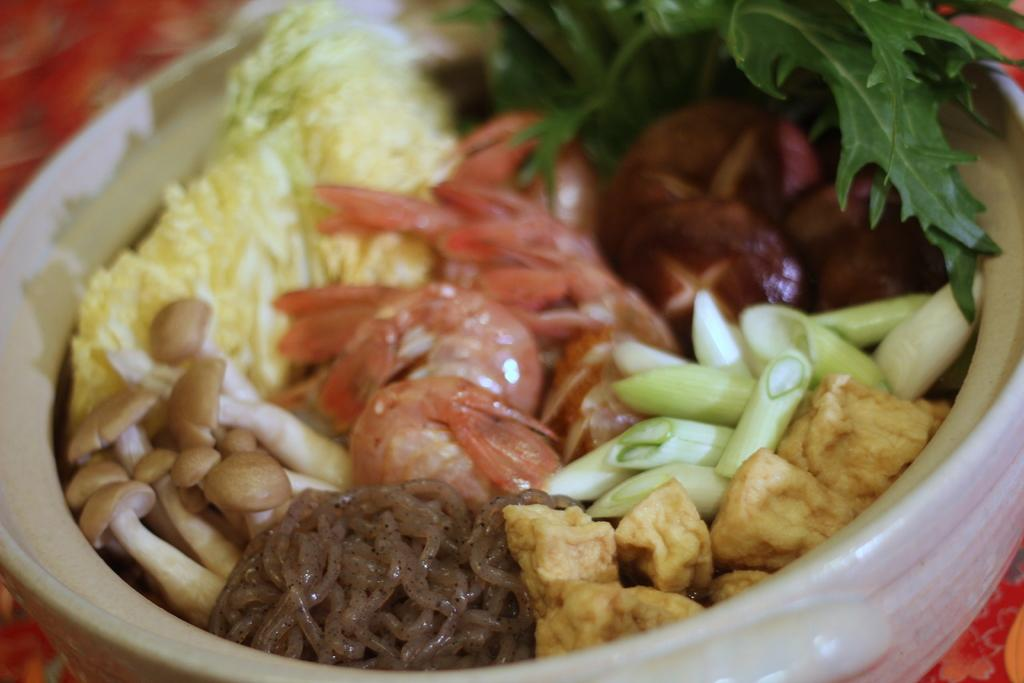What types of items can be seen in the image? There are food items and leaves in the image. How are the food items and leaves arranged in the image? The food items and leaves are in a bowl. What is the color of the surface the bowl is placed on? The bowl is on a red color surface. What type of office appliance can be seen in the image? There is no office appliance present in the image. 